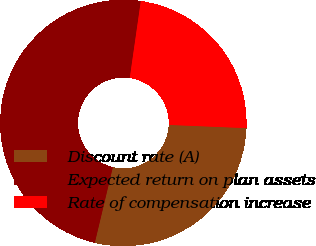<chart> <loc_0><loc_0><loc_500><loc_500><pie_chart><fcel>Discount rate (A)<fcel>Expected return on plan assets<fcel>Rate of compensation increase<nl><fcel>28.07%<fcel>48.54%<fcel>23.39%<nl></chart> 